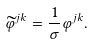<formula> <loc_0><loc_0><loc_500><loc_500>\widetilde { \varphi } ^ { j k } = \frac { 1 } { \sigma } \varphi ^ { j k } .</formula> 